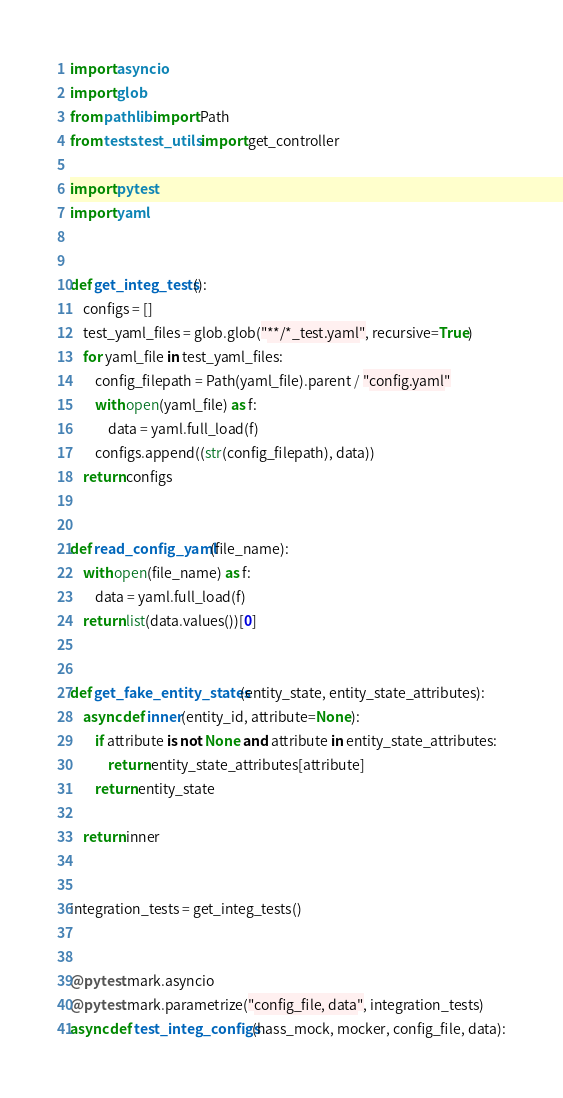Convert code to text. <code><loc_0><loc_0><loc_500><loc_500><_Python_>import asyncio
import glob
from pathlib import Path
from tests.test_utils import get_controller

import pytest
import yaml


def get_integ_tests():
    configs = []
    test_yaml_files = glob.glob("**/*_test.yaml", recursive=True)
    for yaml_file in test_yaml_files:
        config_filepath = Path(yaml_file).parent / "config.yaml"
        with open(yaml_file) as f:
            data = yaml.full_load(f)
        configs.append((str(config_filepath), data))
    return configs


def read_config_yaml(file_name):
    with open(file_name) as f:
        data = yaml.full_load(f)
    return list(data.values())[0]


def get_fake_entity_states(entity_state, entity_state_attributes):
    async def inner(entity_id, attribute=None):
        if attribute is not None and attribute in entity_state_attributes:
            return entity_state_attributes[attribute]
        return entity_state

    return inner


integration_tests = get_integ_tests()


@pytest.mark.asyncio
@pytest.mark.parametrize("config_file, data", integration_tests)
async def test_integ_configs(hass_mock, mocker, config_file, data):</code> 